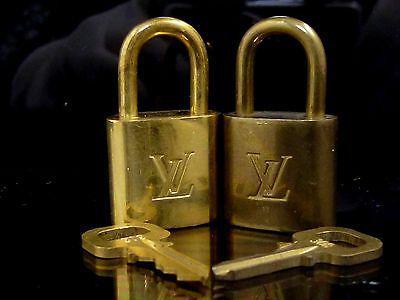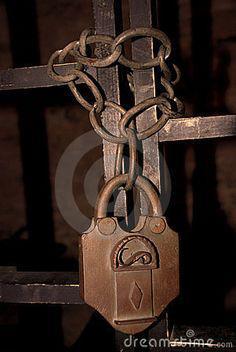The first image is the image on the left, the second image is the image on the right. Analyze the images presented: Is the assertion "An image shows a rusty brownish chain attached to at least one lock, in front of brownish bars." valid? Answer yes or no. Yes. 